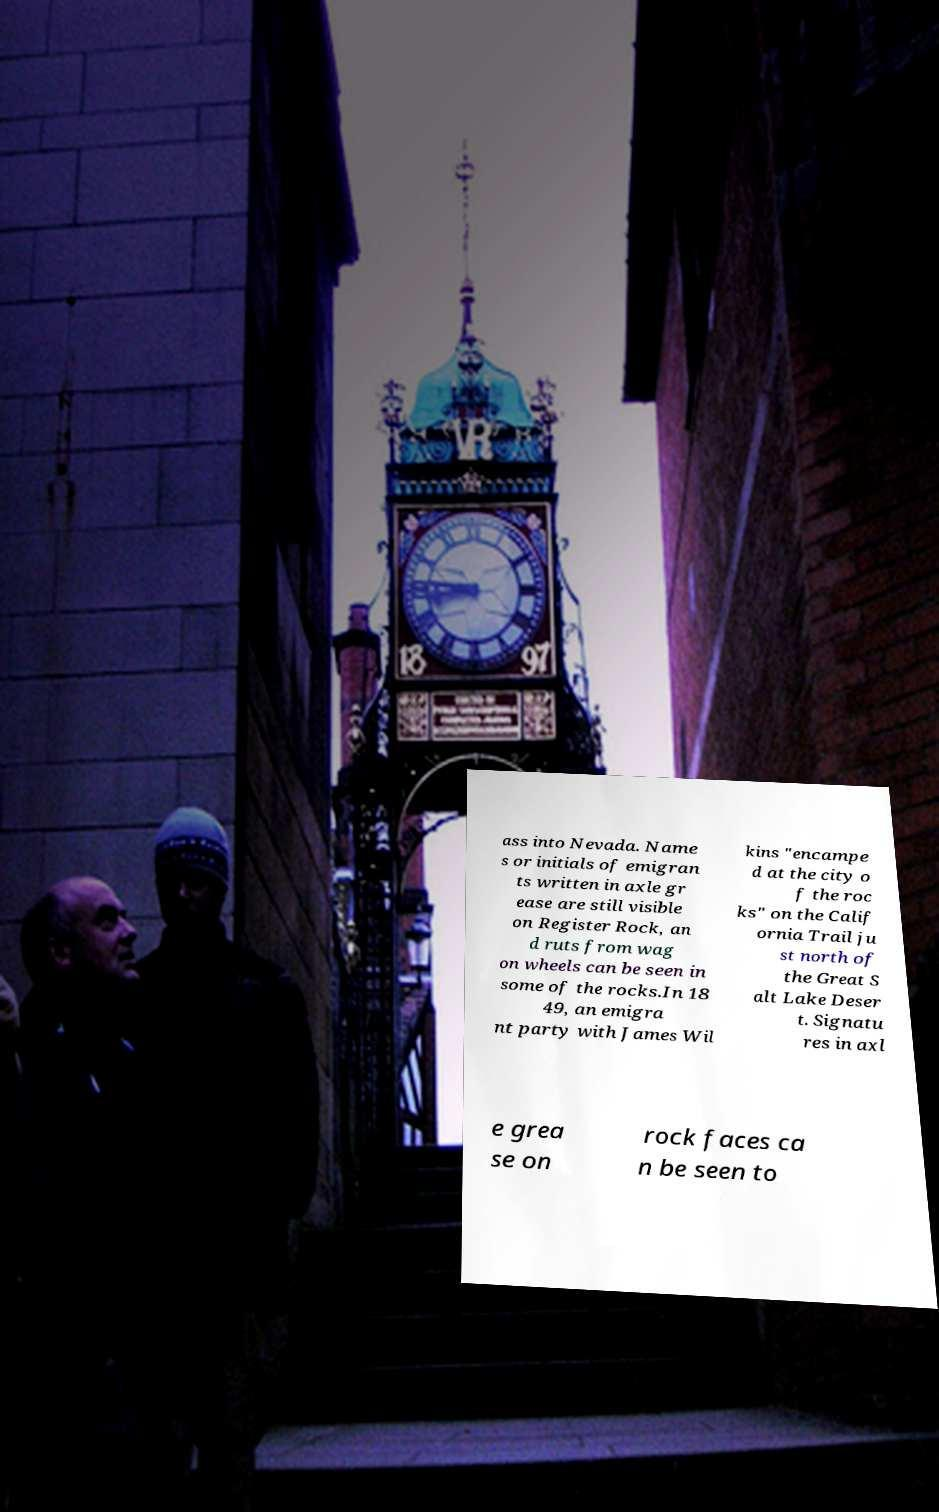What messages or text are displayed in this image? I need them in a readable, typed format. ass into Nevada. Name s or initials of emigran ts written in axle gr ease are still visible on Register Rock, an d ruts from wag on wheels can be seen in some of the rocks.In 18 49, an emigra nt party with James Wil kins "encampe d at the city o f the roc ks" on the Calif ornia Trail ju st north of the Great S alt Lake Deser t. Signatu res in axl e grea se on rock faces ca n be seen to 